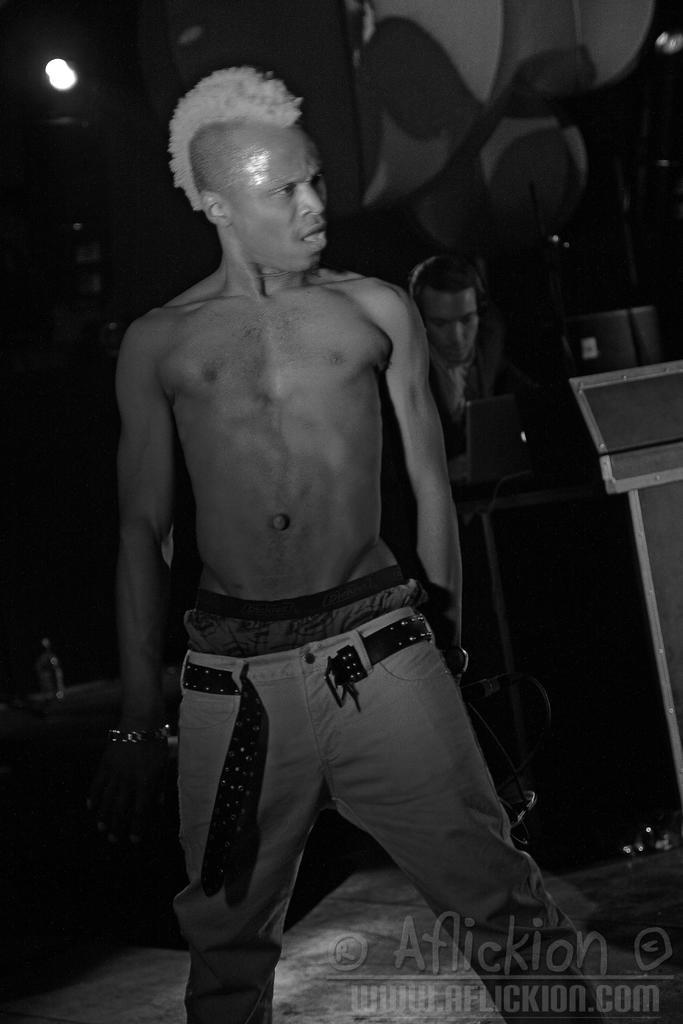How would you summarize this image in a sentence or two? In this image we can see two people, among them one person is standing and the other person is sitting and working on a laptop, there are some objects and the background is blurred. 